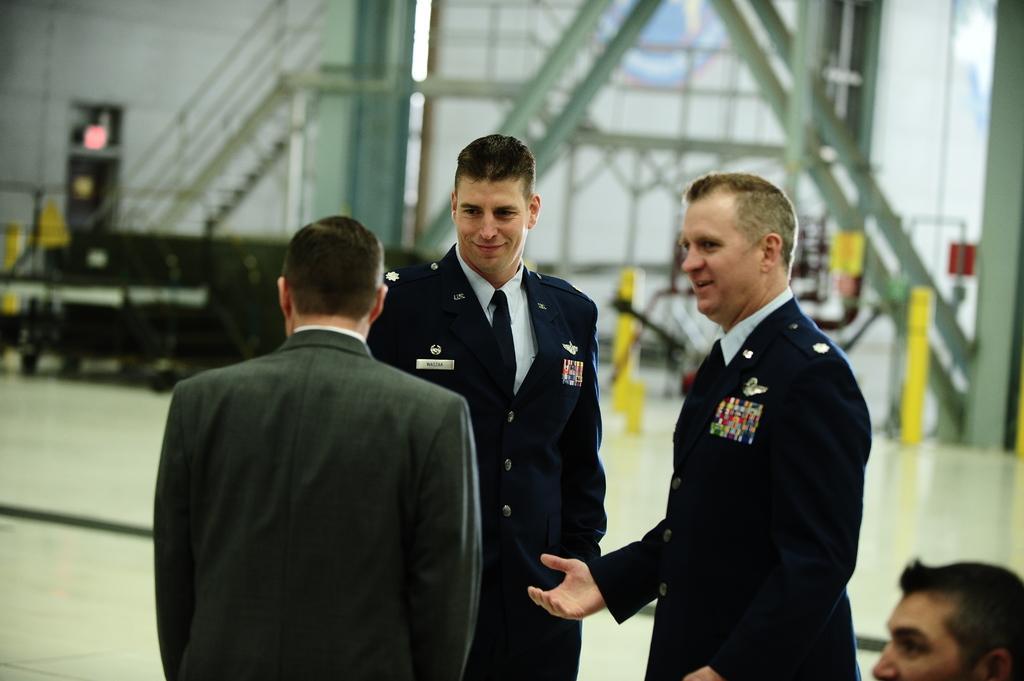Can you describe this image briefly? Here men are standing, this is iron structure. 